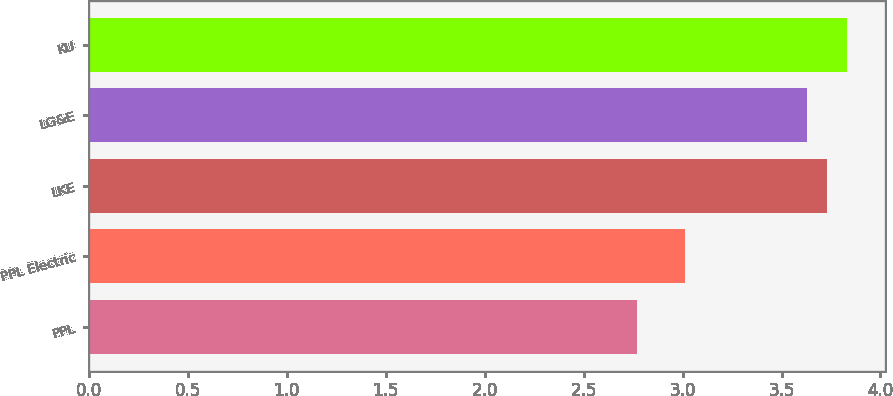Convert chart to OTSL. <chart><loc_0><loc_0><loc_500><loc_500><bar_chart><fcel>PPL<fcel>PPL Electric<fcel>LKE<fcel>LG&E<fcel>KU<nl><fcel>2.77<fcel>3.01<fcel>3.73<fcel>3.63<fcel>3.83<nl></chart> 